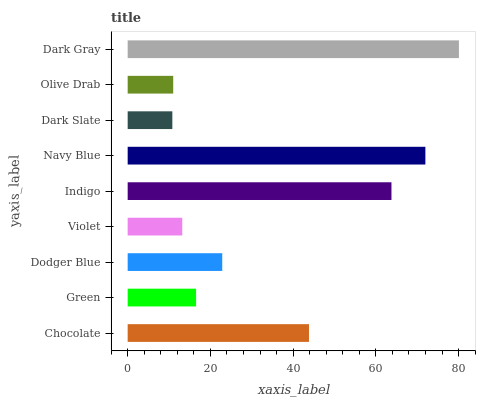Is Dark Slate the minimum?
Answer yes or no. Yes. Is Dark Gray the maximum?
Answer yes or no. Yes. Is Green the minimum?
Answer yes or no. No. Is Green the maximum?
Answer yes or no. No. Is Chocolate greater than Green?
Answer yes or no. Yes. Is Green less than Chocolate?
Answer yes or no. Yes. Is Green greater than Chocolate?
Answer yes or no. No. Is Chocolate less than Green?
Answer yes or no. No. Is Dodger Blue the high median?
Answer yes or no. Yes. Is Dodger Blue the low median?
Answer yes or no. Yes. Is Olive Drab the high median?
Answer yes or no. No. Is Chocolate the low median?
Answer yes or no. No. 